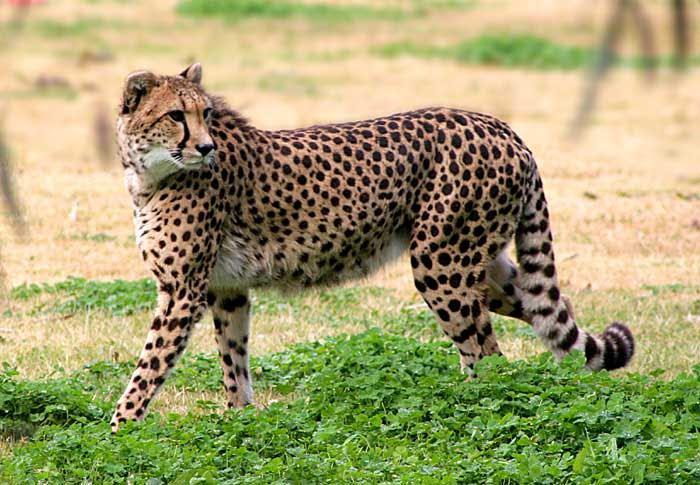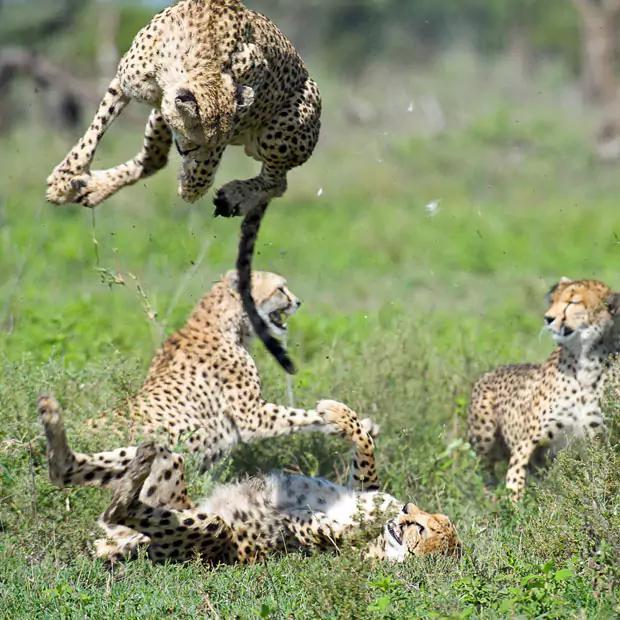The first image is the image on the left, the second image is the image on the right. Examine the images to the left and right. Is the description "The left image contains at least three spotted wild cats." accurate? Answer yes or no. No. The first image is the image on the left, the second image is the image on the right. Considering the images on both sides, is "At least one of the animals is movie fast." valid? Answer yes or no. Yes. 